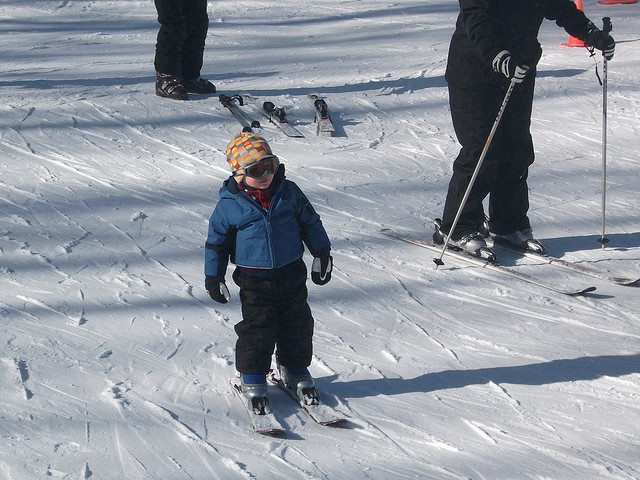Describe the objects in this image and their specific colors. I can see people in gray, black, darkgray, and lightgray tones, people in gray, black, navy, and blue tones, people in gray, black, and darkgray tones, skis in gray, darkgray, lightgray, and black tones, and skis in gray, darkgray, black, and lightgray tones in this image. 